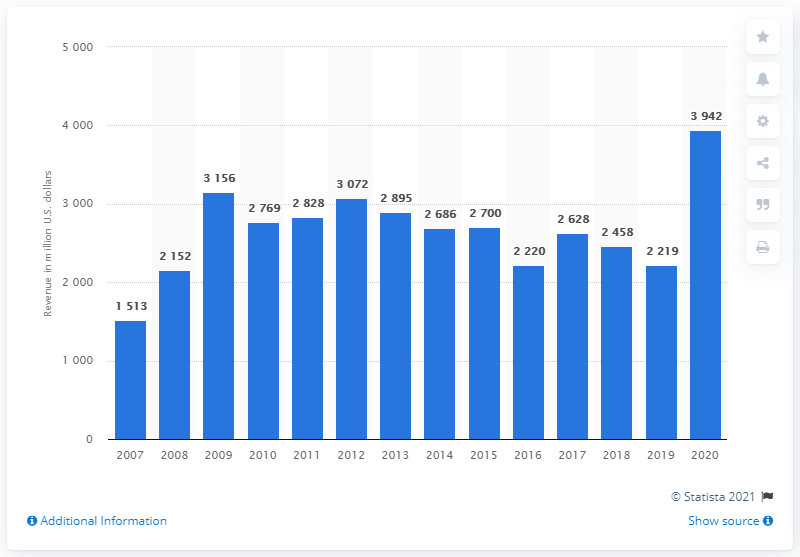Point out several critical features in this image. Activision generated approximately 3942 million dollars in revenue in 2020. In the previous year, Activision generated approximately 22,190 million US dollars in revenue. 